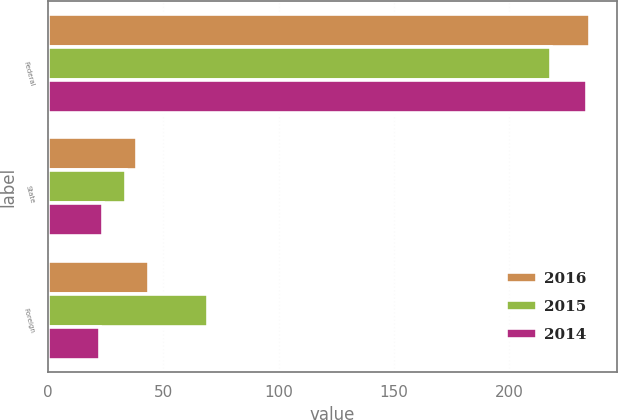Convert chart. <chart><loc_0><loc_0><loc_500><loc_500><stacked_bar_chart><ecel><fcel>Federal<fcel>State<fcel>Foreign<nl><fcel>2016<fcel>235.1<fcel>38.6<fcel>43.9<nl><fcel>2015<fcel>218.3<fcel>33.7<fcel>69.4<nl><fcel>2014<fcel>233.6<fcel>24<fcel>22.7<nl></chart> 